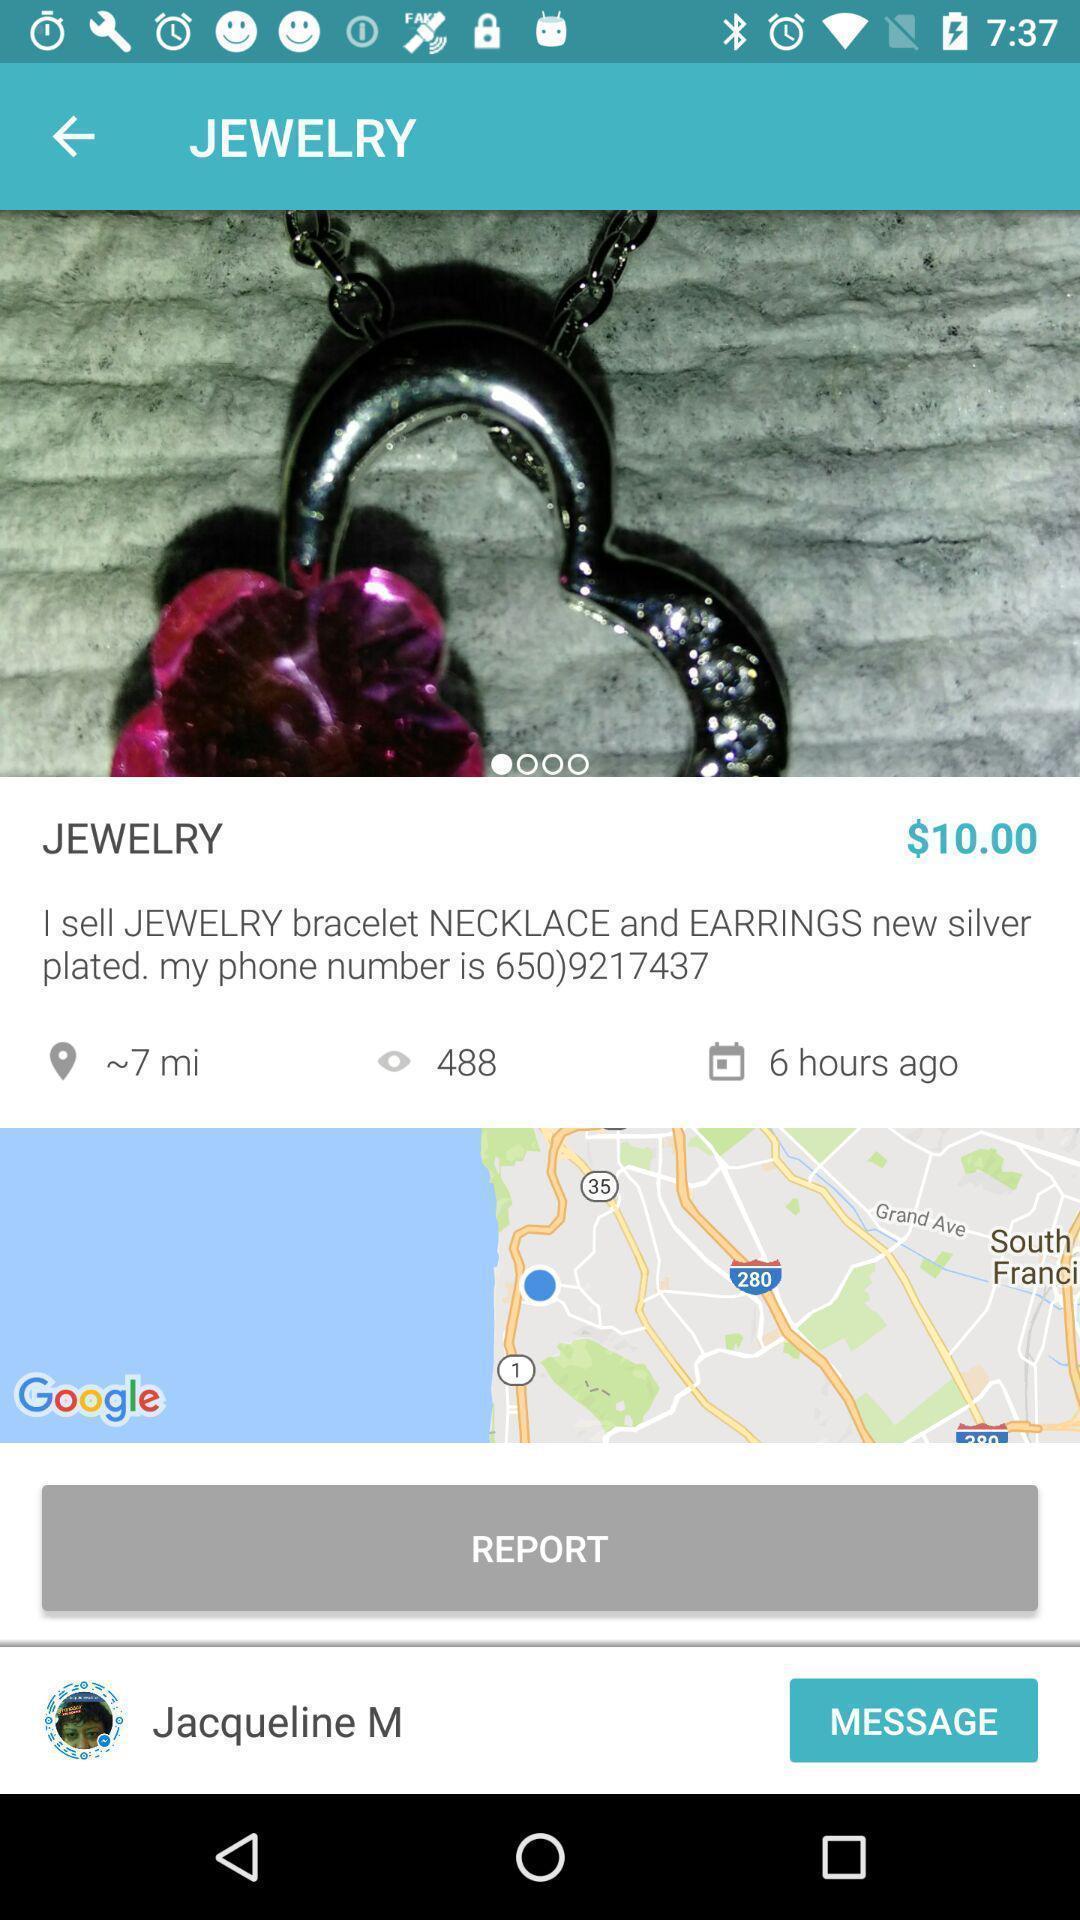Describe the content in this image. Page showing jewelry with price. 